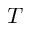<formula> <loc_0><loc_0><loc_500><loc_500>T</formula> 